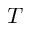<formula> <loc_0><loc_0><loc_500><loc_500>T</formula> 